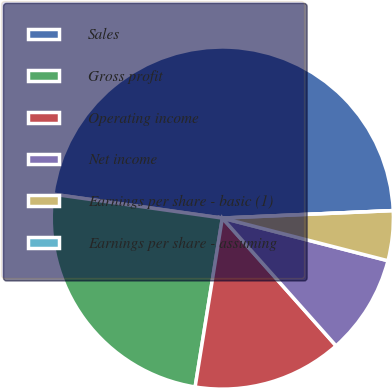Convert chart. <chart><loc_0><loc_0><loc_500><loc_500><pie_chart><fcel>Sales<fcel>Gross profit<fcel>Operating income<fcel>Net income<fcel>Earnings per share - basic (1)<fcel>Earnings per share - assuming<nl><fcel>47.07%<fcel>24.69%<fcel>14.12%<fcel>9.41%<fcel>4.71%<fcel>0.0%<nl></chart> 